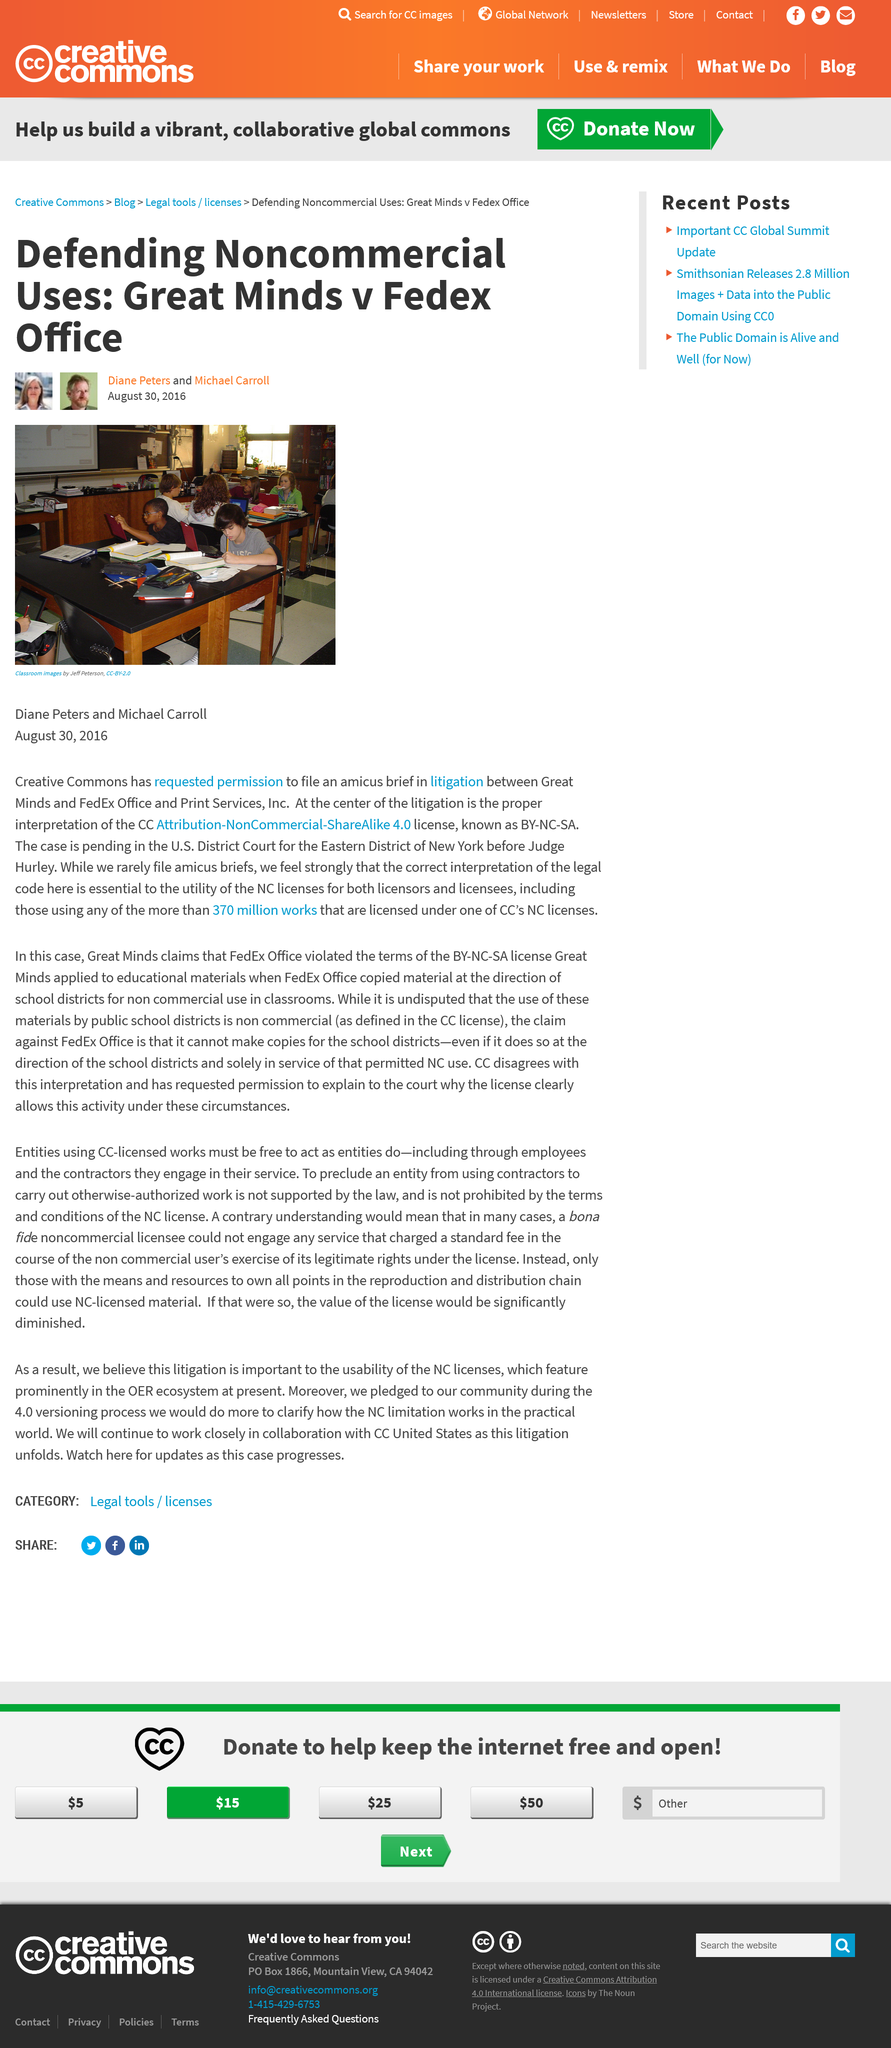Outline some significant characteristics in this image. I, Jeff Peterson, took the image of a classroom. In 2016, Creative Commons filed an amicus brief in a lawsuit between Great Minds and Fedex Office and Print Services, Inc. The NC in NC licenses stands for non-commercial, as declared. 